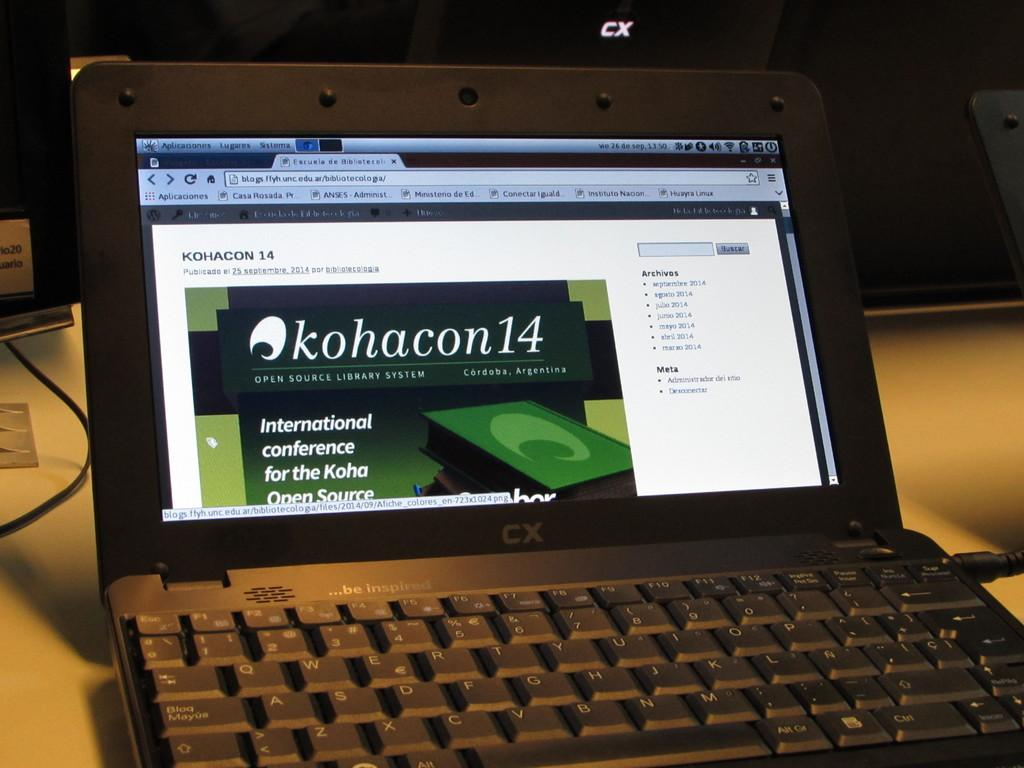<image>
Provide a brief description of the given image. A small black laptop with a web page referring to an international conference. 